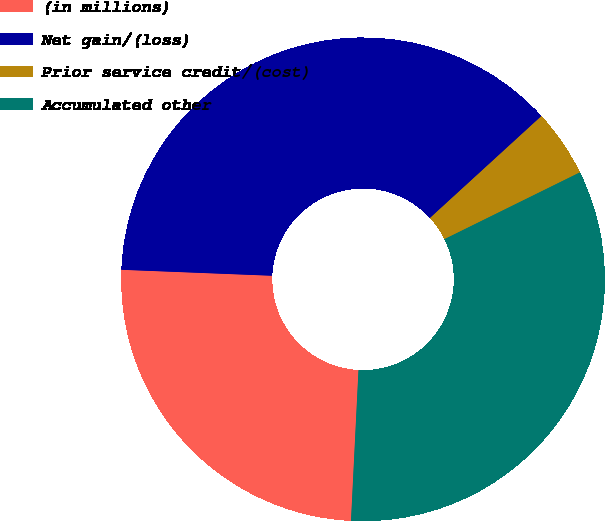Convert chart. <chart><loc_0><loc_0><loc_500><loc_500><pie_chart><fcel>(in millions)<fcel>Net gain/(loss)<fcel>Prior service credit/(cost)<fcel>Accumulated other<nl><fcel>24.84%<fcel>37.58%<fcel>4.5%<fcel>33.08%<nl></chart> 